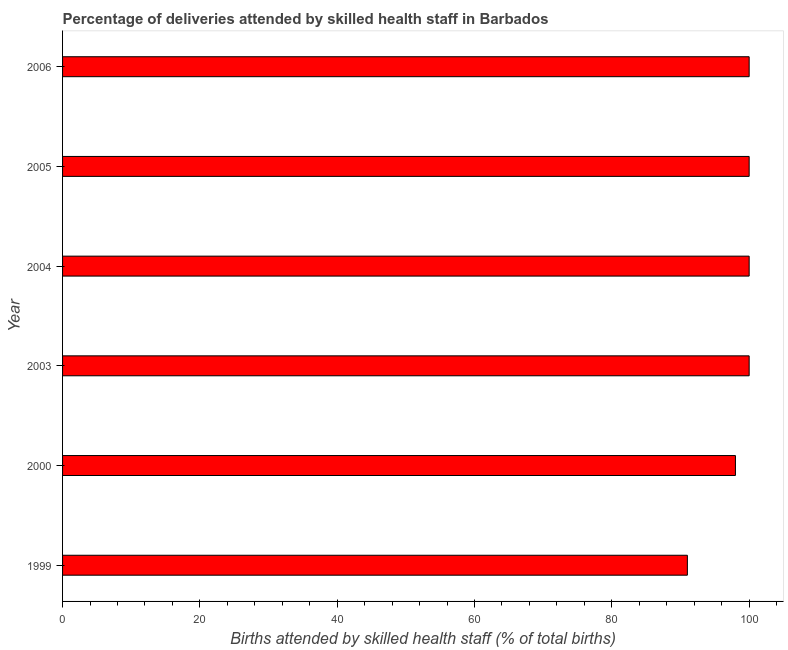What is the title of the graph?
Provide a short and direct response. Percentage of deliveries attended by skilled health staff in Barbados. What is the label or title of the X-axis?
Provide a succinct answer. Births attended by skilled health staff (% of total births). What is the label or title of the Y-axis?
Make the answer very short. Year. What is the number of births attended by skilled health staff in 2000?
Ensure brevity in your answer.  98. Across all years, what is the minimum number of births attended by skilled health staff?
Your answer should be very brief. 91. What is the sum of the number of births attended by skilled health staff?
Keep it short and to the point. 589. What is the average number of births attended by skilled health staff per year?
Provide a succinct answer. 98. What is the ratio of the number of births attended by skilled health staff in 1999 to that in 2006?
Ensure brevity in your answer.  0.91. Is the number of births attended by skilled health staff in 2000 less than that in 2006?
Your response must be concise. Yes. Is the difference between the number of births attended by skilled health staff in 2003 and 2005 greater than the difference between any two years?
Make the answer very short. No. What is the difference between the highest and the lowest number of births attended by skilled health staff?
Your answer should be very brief. 9. In how many years, is the number of births attended by skilled health staff greater than the average number of births attended by skilled health staff taken over all years?
Offer a terse response. 4. How many bars are there?
Your answer should be compact. 6. Are the values on the major ticks of X-axis written in scientific E-notation?
Keep it short and to the point. No. What is the Births attended by skilled health staff (% of total births) of 1999?
Ensure brevity in your answer.  91. What is the Births attended by skilled health staff (% of total births) of 2003?
Provide a succinct answer. 100. What is the Births attended by skilled health staff (% of total births) of 2004?
Offer a terse response. 100. What is the difference between the Births attended by skilled health staff (% of total births) in 1999 and 2004?
Keep it short and to the point. -9. What is the difference between the Births attended by skilled health staff (% of total births) in 1999 and 2005?
Provide a succinct answer. -9. What is the difference between the Births attended by skilled health staff (% of total births) in 1999 and 2006?
Offer a very short reply. -9. What is the difference between the Births attended by skilled health staff (% of total births) in 2000 and 2005?
Keep it short and to the point. -2. What is the difference between the Births attended by skilled health staff (% of total births) in 2000 and 2006?
Provide a short and direct response. -2. What is the difference between the Births attended by skilled health staff (% of total births) in 2003 and 2004?
Provide a short and direct response. 0. What is the difference between the Births attended by skilled health staff (% of total births) in 2004 and 2005?
Your response must be concise. 0. What is the ratio of the Births attended by skilled health staff (% of total births) in 1999 to that in 2000?
Your response must be concise. 0.93. What is the ratio of the Births attended by skilled health staff (% of total births) in 1999 to that in 2003?
Give a very brief answer. 0.91. What is the ratio of the Births attended by skilled health staff (% of total births) in 1999 to that in 2004?
Offer a very short reply. 0.91. What is the ratio of the Births attended by skilled health staff (% of total births) in 1999 to that in 2005?
Your answer should be very brief. 0.91. What is the ratio of the Births attended by skilled health staff (% of total births) in 1999 to that in 2006?
Ensure brevity in your answer.  0.91. What is the ratio of the Births attended by skilled health staff (% of total births) in 2000 to that in 2003?
Provide a succinct answer. 0.98. What is the ratio of the Births attended by skilled health staff (% of total births) in 2000 to that in 2004?
Ensure brevity in your answer.  0.98. What is the ratio of the Births attended by skilled health staff (% of total births) in 2000 to that in 2006?
Provide a succinct answer. 0.98. What is the ratio of the Births attended by skilled health staff (% of total births) in 2003 to that in 2004?
Keep it short and to the point. 1. 